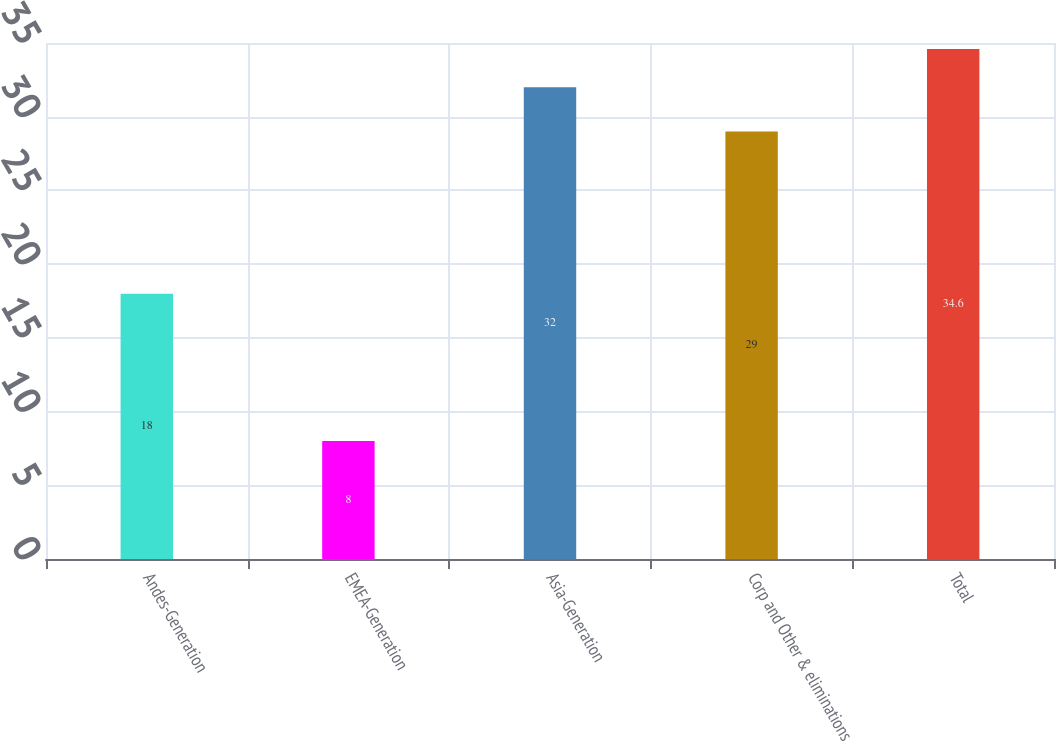Convert chart to OTSL. <chart><loc_0><loc_0><loc_500><loc_500><bar_chart><fcel>Andes-Generation<fcel>EMEA-Generation<fcel>Asia-Generation<fcel>Corp and Other & eliminations<fcel>Total<nl><fcel>18<fcel>8<fcel>32<fcel>29<fcel>34.6<nl></chart> 